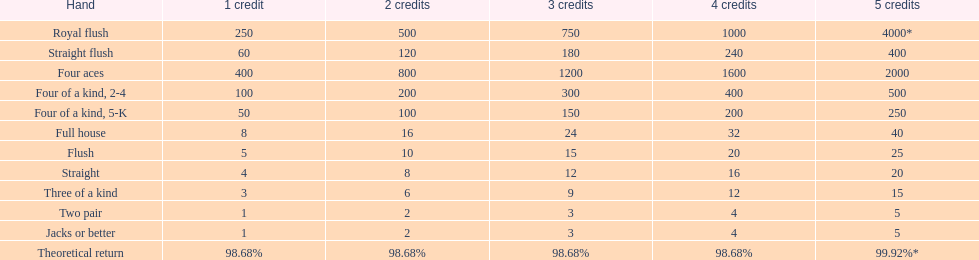Which is a higher standing hand: a straight or a flush? Flush. 